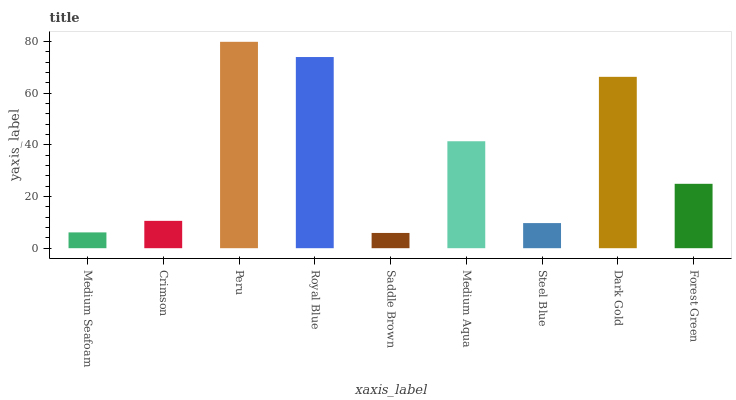Is Saddle Brown the minimum?
Answer yes or no. Yes. Is Peru the maximum?
Answer yes or no. Yes. Is Crimson the minimum?
Answer yes or no. No. Is Crimson the maximum?
Answer yes or no. No. Is Crimson greater than Medium Seafoam?
Answer yes or no. Yes. Is Medium Seafoam less than Crimson?
Answer yes or no. Yes. Is Medium Seafoam greater than Crimson?
Answer yes or no. No. Is Crimson less than Medium Seafoam?
Answer yes or no. No. Is Forest Green the high median?
Answer yes or no. Yes. Is Forest Green the low median?
Answer yes or no. Yes. Is Saddle Brown the high median?
Answer yes or no. No. Is Crimson the low median?
Answer yes or no. No. 